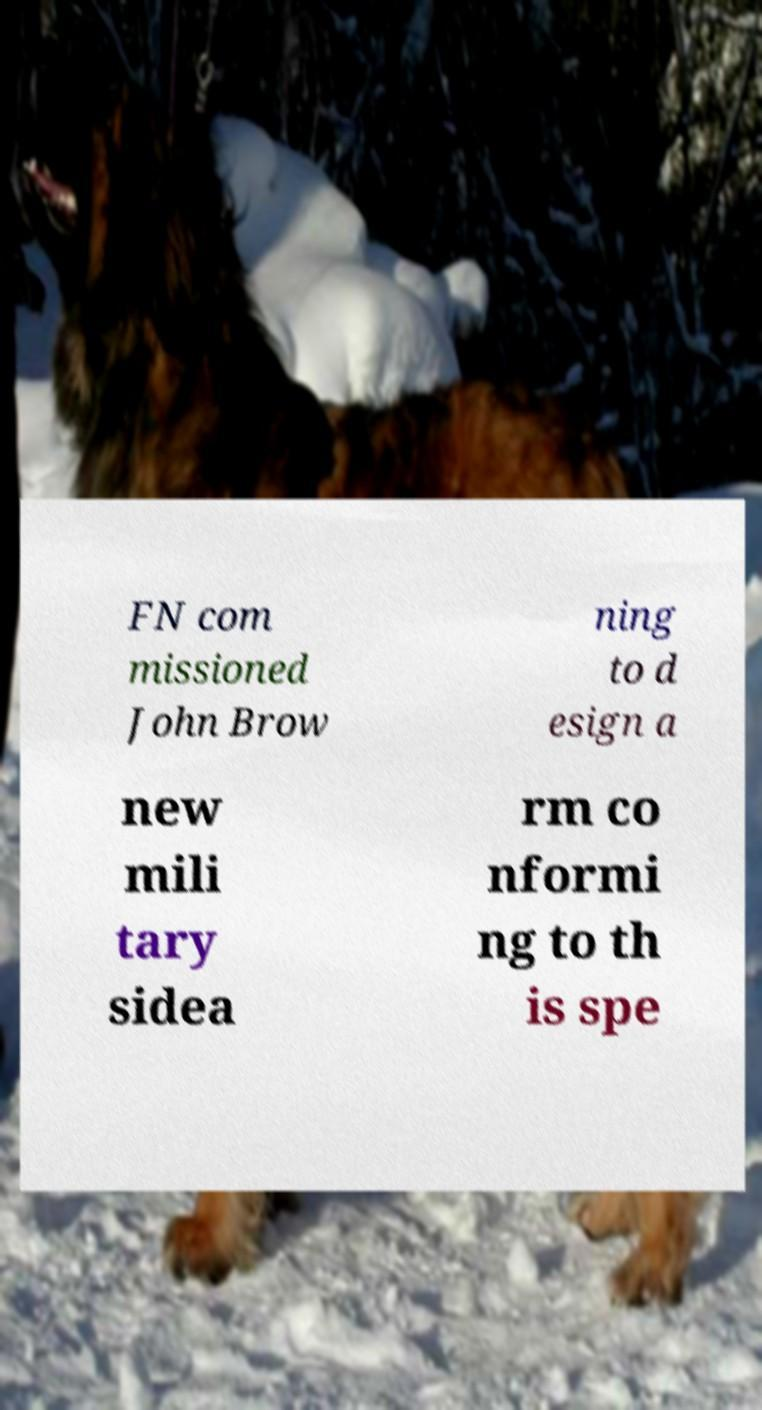Please read and relay the text visible in this image. What does it say? FN com missioned John Brow ning to d esign a new mili tary sidea rm co nformi ng to th is spe 